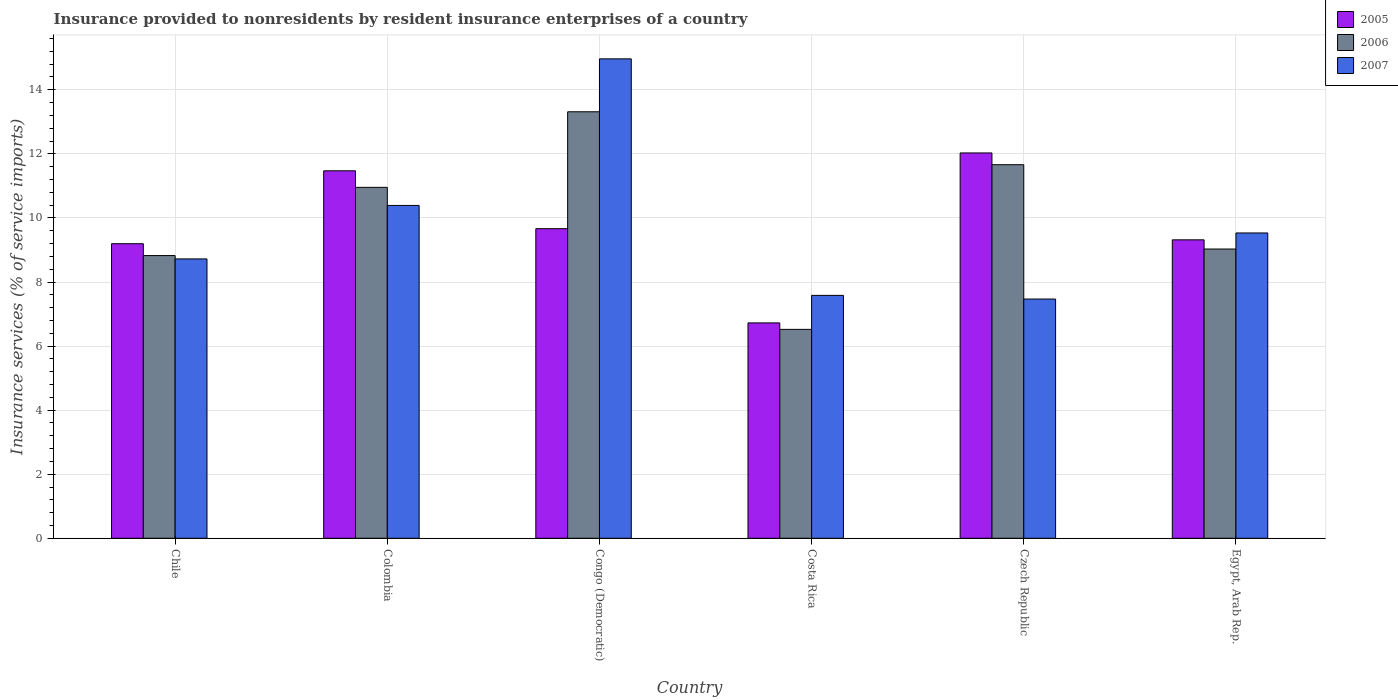How many different coloured bars are there?
Your answer should be very brief. 3. How many groups of bars are there?
Give a very brief answer. 6. Are the number of bars per tick equal to the number of legend labels?
Your answer should be very brief. Yes. Are the number of bars on each tick of the X-axis equal?
Your answer should be very brief. Yes. How many bars are there on the 1st tick from the left?
Your answer should be compact. 3. How many bars are there on the 1st tick from the right?
Your response must be concise. 3. What is the label of the 5th group of bars from the left?
Provide a short and direct response. Czech Republic. What is the insurance provided to nonresidents in 2005 in Czech Republic?
Offer a terse response. 12.03. Across all countries, what is the maximum insurance provided to nonresidents in 2007?
Offer a terse response. 14.97. Across all countries, what is the minimum insurance provided to nonresidents in 2006?
Offer a terse response. 6.52. In which country was the insurance provided to nonresidents in 2006 maximum?
Offer a very short reply. Congo (Democratic). In which country was the insurance provided to nonresidents in 2007 minimum?
Make the answer very short. Czech Republic. What is the total insurance provided to nonresidents in 2005 in the graph?
Your answer should be compact. 58.4. What is the difference between the insurance provided to nonresidents in 2005 in Costa Rica and that in Egypt, Arab Rep.?
Ensure brevity in your answer.  -2.59. What is the difference between the insurance provided to nonresidents in 2005 in Colombia and the insurance provided to nonresidents in 2007 in Czech Republic?
Give a very brief answer. 4. What is the average insurance provided to nonresidents in 2007 per country?
Your answer should be very brief. 9.78. What is the difference between the insurance provided to nonresidents of/in 2007 and insurance provided to nonresidents of/in 2006 in Costa Rica?
Your response must be concise. 1.06. In how many countries, is the insurance provided to nonresidents in 2006 greater than 14 %?
Provide a succinct answer. 0. What is the ratio of the insurance provided to nonresidents in 2006 in Czech Republic to that in Egypt, Arab Rep.?
Your answer should be very brief. 1.29. What is the difference between the highest and the second highest insurance provided to nonresidents in 2007?
Ensure brevity in your answer.  -0.86. What is the difference between the highest and the lowest insurance provided to nonresidents in 2007?
Your response must be concise. 7.5. In how many countries, is the insurance provided to nonresidents in 2005 greater than the average insurance provided to nonresidents in 2005 taken over all countries?
Keep it short and to the point. 2. Is the sum of the insurance provided to nonresidents in 2006 in Chile and Costa Rica greater than the maximum insurance provided to nonresidents in 2005 across all countries?
Your answer should be compact. Yes. Are all the bars in the graph horizontal?
Your answer should be compact. No. How many countries are there in the graph?
Give a very brief answer. 6. Does the graph contain any zero values?
Your answer should be compact. No. Does the graph contain grids?
Make the answer very short. Yes. Where does the legend appear in the graph?
Your answer should be very brief. Top right. What is the title of the graph?
Offer a terse response. Insurance provided to nonresidents by resident insurance enterprises of a country. What is the label or title of the X-axis?
Offer a very short reply. Country. What is the label or title of the Y-axis?
Make the answer very short. Insurance services (% of service imports). What is the Insurance services (% of service imports) in 2005 in Chile?
Provide a succinct answer. 9.2. What is the Insurance services (% of service imports) in 2006 in Chile?
Offer a very short reply. 8.83. What is the Insurance services (% of service imports) of 2007 in Chile?
Provide a short and direct response. 8.72. What is the Insurance services (% of service imports) in 2005 in Colombia?
Your answer should be very brief. 11.47. What is the Insurance services (% of service imports) of 2006 in Colombia?
Give a very brief answer. 10.96. What is the Insurance services (% of service imports) of 2007 in Colombia?
Your response must be concise. 10.39. What is the Insurance services (% of service imports) of 2005 in Congo (Democratic)?
Make the answer very short. 9.66. What is the Insurance services (% of service imports) in 2006 in Congo (Democratic)?
Offer a very short reply. 13.31. What is the Insurance services (% of service imports) in 2007 in Congo (Democratic)?
Give a very brief answer. 14.97. What is the Insurance services (% of service imports) of 2005 in Costa Rica?
Make the answer very short. 6.72. What is the Insurance services (% of service imports) in 2006 in Costa Rica?
Offer a terse response. 6.52. What is the Insurance services (% of service imports) in 2007 in Costa Rica?
Provide a short and direct response. 7.58. What is the Insurance services (% of service imports) in 2005 in Czech Republic?
Provide a succinct answer. 12.03. What is the Insurance services (% of service imports) in 2006 in Czech Republic?
Ensure brevity in your answer.  11.66. What is the Insurance services (% of service imports) of 2007 in Czech Republic?
Offer a terse response. 7.47. What is the Insurance services (% of service imports) in 2005 in Egypt, Arab Rep.?
Keep it short and to the point. 9.32. What is the Insurance services (% of service imports) of 2006 in Egypt, Arab Rep.?
Offer a terse response. 9.03. What is the Insurance services (% of service imports) in 2007 in Egypt, Arab Rep.?
Provide a short and direct response. 9.53. Across all countries, what is the maximum Insurance services (% of service imports) of 2005?
Give a very brief answer. 12.03. Across all countries, what is the maximum Insurance services (% of service imports) in 2006?
Provide a succinct answer. 13.31. Across all countries, what is the maximum Insurance services (% of service imports) in 2007?
Offer a terse response. 14.97. Across all countries, what is the minimum Insurance services (% of service imports) in 2005?
Your answer should be very brief. 6.72. Across all countries, what is the minimum Insurance services (% of service imports) in 2006?
Ensure brevity in your answer.  6.52. Across all countries, what is the minimum Insurance services (% of service imports) in 2007?
Provide a succinct answer. 7.47. What is the total Insurance services (% of service imports) in 2005 in the graph?
Provide a short and direct response. 58.4. What is the total Insurance services (% of service imports) in 2006 in the graph?
Provide a short and direct response. 60.31. What is the total Insurance services (% of service imports) in 2007 in the graph?
Provide a succinct answer. 58.66. What is the difference between the Insurance services (% of service imports) in 2005 in Chile and that in Colombia?
Give a very brief answer. -2.28. What is the difference between the Insurance services (% of service imports) in 2006 in Chile and that in Colombia?
Offer a terse response. -2.13. What is the difference between the Insurance services (% of service imports) in 2007 in Chile and that in Colombia?
Offer a terse response. -1.67. What is the difference between the Insurance services (% of service imports) in 2005 in Chile and that in Congo (Democratic)?
Provide a short and direct response. -0.47. What is the difference between the Insurance services (% of service imports) of 2006 in Chile and that in Congo (Democratic)?
Your answer should be very brief. -4.49. What is the difference between the Insurance services (% of service imports) of 2007 in Chile and that in Congo (Democratic)?
Offer a terse response. -6.25. What is the difference between the Insurance services (% of service imports) of 2005 in Chile and that in Costa Rica?
Make the answer very short. 2.47. What is the difference between the Insurance services (% of service imports) of 2006 in Chile and that in Costa Rica?
Offer a very short reply. 2.3. What is the difference between the Insurance services (% of service imports) in 2007 in Chile and that in Costa Rica?
Make the answer very short. 1.14. What is the difference between the Insurance services (% of service imports) of 2005 in Chile and that in Czech Republic?
Your answer should be compact. -2.83. What is the difference between the Insurance services (% of service imports) of 2006 in Chile and that in Czech Republic?
Provide a short and direct response. -2.84. What is the difference between the Insurance services (% of service imports) in 2007 in Chile and that in Czech Republic?
Keep it short and to the point. 1.25. What is the difference between the Insurance services (% of service imports) in 2005 in Chile and that in Egypt, Arab Rep.?
Offer a very short reply. -0.12. What is the difference between the Insurance services (% of service imports) in 2006 in Chile and that in Egypt, Arab Rep.?
Your response must be concise. -0.2. What is the difference between the Insurance services (% of service imports) in 2007 in Chile and that in Egypt, Arab Rep.?
Ensure brevity in your answer.  -0.81. What is the difference between the Insurance services (% of service imports) of 2005 in Colombia and that in Congo (Democratic)?
Offer a very short reply. 1.81. What is the difference between the Insurance services (% of service imports) of 2006 in Colombia and that in Congo (Democratic)?
Your answer should be very brief. -2.36. What is the difference between the Insurance services (% of service imports) of 2007 in Colombia and that in Congo (Democratic)?
Your answer should be compact. -4.58. What is the difference between the Insurance services (% of service imports) of 2005 in Colombia and that in Costa Rica?
Provide a short and direct response. 4.75. What is the difference between the Insurance services (% of service imports) in 2006 in Colombia and that in Costa Rica?
Offer a terse response. 4.43. What is the difference between the Insurance services (% of service imports) in 2007 in Colombia and that in Costa Rica?
Your response must be concise. 2.81. What is the difference between the Insurance services (% of service imports) of 2005 in Colombia and that in Czech Republic?
Ensure brevity in your answer.  -0.56. What is the difference between the Insurance services (% of service imports) of 2006 in Colombia and that in Czech Republic?
Offer a terse response. -0.71. What is the difference between the Insurance services (% of service imports) of 2007 in Colombia and that in Czech Republic?
Give a very brief answer. 2.92. What is the difference between the Insurance services (% of service imports) of 2005 in Colombia and that in Egypt, Arab Rep.?
Make the answer very short. 2.16. What is the difference between the Insurance services (% of service imports) of 2006 in Colombia and that in Egypt, Arab Rep.?
Your answer should be very brief. 1.93. What is the difference between the Insurance services (% of service imports) of 2007 in Colombia and that in Egypt, Arab Rep.?
Keep it short and to the point. 0.86. What is the difference between the Insurance services (% of service imports) in 2005 in Congo (Democratic) and that in Costa Rica?
Provide a short and direct response. 2.94. What is the difference between the Insurance services (% of service imports) in 2006 in Congo (Democratic) and that in Costa Rica?
Offer a very short reply. 6.79. What is the difference between the Insurance services (% of service imports) of 2007 in Congo (Democratic) and that in Costa Rica?
Provide a short and direct response. 7.38. What is the difference between the Insurance services (% of service imports) of 2005 in Congo (Democratic) and that in Czech Republic?
Offer a terse response. -2.36. What is the difference between the Insurance services (% of service imports) in 2006 in Congo (Democratic) and that in Czech Republic?
Provide a short and direct response. 1.65. What is the difference between the Insurance services (% of service imports) of 2007 in Congo (Democratic) and that in Czech Republic?
Keep it short and to the point. 7.5. What is the difference between the Insurance services (% of service imports) in 2005 in Congo (Democratic) and that in Egypt, Arab Rep.?
Give a very brief answer. 0.35. What is the difference between the Insurance services (% of service imports) of 2006 in Congo (Democratic) and that in Egypt, Arab Rep.?
Offer a very short reply. 4.28. What is the difference between the Insurance services (% of service imports) of 2007 in Congo (Democratic) and that in Egypt, Arab Rep.?
Ensure brevity in your answer.  5.44. What is the difference between the Insurance services (% of service imports) in 2005 in Costa Rica and that in Czech Republic?
Provide a short and direct response. -5.31. What is the difference between the Insurance services (% of service imports) of 2006 in Costa Rica and that in Czech Republic?
Offer a very short reply. -5.14. What is the difference between the Insurance services (% of service imports) in 2007 in Costa Rica and that in Czech Republic?
Give a very brief answer. 0.11. What is the difference between the Insurance services (% of service imports) in 2005 in Costa Rica and that in Egypt, Arab Rep.?
Provide a short and direct response. -2.59. What is the difference between the Insurance services (% of service imports) of 2006 in Costa Rica and that in Egypt, Arab Rep.?
Your answer should be compact. -2.51. What is the difference between the Insurance services (% of service imports) of 2007 in Costa Rica and that in Egypt, Arab Rep.?
Offer a very short reply. -1.95. What is the difference between the Insurance services (% of service imports) of 2005 in Czech Republic and that in Egypt, Arab Rep.?
Your answer should be compact. 2.71. What is the difference between the Insurance services (% of service imports) of 2006 in Czech Republic and that in Egypt, Arab Rep.?
Ensure brevity in your answer.  2.63. What is the difference between the Insurance services (% of service imports) in 2007 in Czech Republic and that in Egypt, Arab Rep.?
Your response must be concise. -2.06. What is the difference between the Insurance services (% of service imports) in 2005 in Chile and the Insurance services (% of service imports) in 2006 in Colombia?
Ensure brevity in your answer.  -1.76. What is the difference between the Insurance services (% of service imports) in 2005 in Chile and the Insurance services (% of service imports) in 2007 in Colombia?
Provide a succinct answer. -1.19. What is the difference between the Insurance services (% of service imports) of 2006 in Chile and the Insurance services (% of service imports) of 2007 in Colombia?
Offer a terse response. -1.57. What is the difference between the Insurance services (% of service imports) of 2005 in Chile and the Insurance services (% of service imports) of 2006 in Congo (Democratic)?
Provide a short and direct response. -4.12. What is the difference between the Insurance services (% of service imports) in 2005 in Chile and the Insurance services (% of service imports) in 2007 in Congo (Democratic)?
Provide a succinct answer. -5.77. What is the difference between the Insurance services (% of service imports) of 2006 in Chile and the Insurance services (% of service imports) of 2007 in Congo (Democratic)?
Your answer should be compact. -6.14. What is the difference between the Insurance services (% of service imports) of 2005 in Chile and the Insurance services (% of service imports) of 2006 in Costa Rica?
Offer a very short reply. 2.67. What is the difference between the Insurance services (% of service imports) of 2005 in Chile and the Insurance services (% of service imports) of 2007 in Costa Rica?
Your answer should be compact. 1.61. What is the difference between the Insurance services (% of service imports) of 2006 in Chile and the Insurance services (% of service imports) of 2007 in Costa Rica?
Offer a terse response. 1.24. What is the difference between the Insurance services (% of service imports) in 2005 in Chile and the Insurance services (% of service imports) in 2006 in Czech Republic?
Provide a succinct answer. -2.47. What is the difference between the Insurance services (% of service imports) of 2005 in Chile and the Insurance services (% of service imports) of 2007 in Czech Republic?
Your answer should be very brief. 1.73. What is the difference between the Insurance services (% of service imports) of 2006 in Chile and the Insurance services (% of service imports) of 2007 in Czech Republic?
Your response must be concise. 1.36. What is the difference between the Insurance services (% of service imports) of 2005 in Chile and the Insurance services (% of service imports) of 2006 in Egypt, Arab Rep.?
Your answer should be compact. 0.17. What is the difference between the Insurance services (% of service imports) in 2005 in Chile and the Insurance services (% of service imports) in 2007 in Egypt, Arab Rep.?
Give a very brief answer. -0.34. What is the difference between the Insurance services (% of service imports) in 2006 in Chile and the Insurance services (% of service imports) in 2007 in Egypt, Arab Rep.?
Your response must be concise. -0.71. What is the difference between the Insurance services (% of service imports) in 2005 in Colombia and the Insurance services (% of service imports) in 2006 in Congo (Democratic)?
Your answer should be very brief. -1.84. What is the difference between the Insurance services (% of service imports) in 2005 in Colombia and the Insurance services (% of service imports) in 2007 in Congo (Democratic)?
Your answer should be compact. -3.49. What is the difference between the Insurance services (% of service imports) in 2006 in Colombia and the Insurance services (% of service imports) in 2007 in Congo (Democratic)?
Make the answer very short. -4.01. What is the difference between the Insurance services (% of service imports) of 2005 in Colombia and the Insurance services (% of service imports) of 2006 in Costa Rica?
Make the answer very short. 4.95. What is the difference between the Insurance services (% of service imports) in 2005 in Colombia and the Insurance services (% of service imports) in 2007 in Costa Rica?
Provide a short and direct response. 3.89. What is the difference between the Insurance services (% of service imports) of 2006 in Colombia and the Insurance services (% of service imports) of 2007 in Costa Rica?
Your answer should be very brief. 3.37. What is the difference between the Insurance services (% of service imports) in 2005 in Colombia and the Insurance services (% of service imports) in 2006 in Czech Republic?
Ensure brevity in your answer.  -0.19. What is the difference between the Insurance services (% of service imports) in 2005 in Colombia and the Insurance services (% of service imports) in 2007 in Czech Republic?
Make the answer very short. 4. What is the difference between the Insurance services (% of service imports) of 2006 in Colombia and the Insurance services (% of service imports) of 2007 in Czech Republic?
Provide a succinct answer. 3.49. What is the difference between the Insurance services (% of service imports) of 2005 in Colombia and the Insurance services (% of service imports) of 2006 in Egypt, Arab Rep.?
Your response must be concise. 2.44. What is the difference between the Insurance services (% of service imports) of 2005 in Colombia and the Insurance services (% of service imports) of 2007 in Egypt, Arab Rep.?
Provide a succinct answer. 1.94. What is the difference between the Insurance services (% of service imports) of 2006 in Colombia and the Insurance services (% of service imports) of 2007 in Egypt, Arab Rep.?
Offer a terse response. 1.42. What is the difference between the Insurance services (% of service imports) in 2005 in Congo (Democratic) and the Insurance services (% of service imports) in 2006 in Costa Rica?
Provide a short and direct response. 3.14. What is the difference between the Insurance services (% of service imports) of 2005 in Congo (Democratic) and the Insurance services (% of service imports) of 2007 in Costa Rica?
Offer a very short reply. 2.08. What is the difference between the Insurance services (% of service imports) in 2006 in Congo (Democratic) and the Insurance services (% of service imports) in 2007 in Costa Rica?
Offer a terse response. 5.73. What is the difference between the Insurance services (% of service imports) of 2005 in Congo (Democratic) and the Insurance services (% of service imports) of 2006 in Czech Republic?
Your response must be concise. -2. What is the difference between the Insurance services (% of service imports) of 2005 in Congo (Democratic) and the Insurance services (% of service imports) of 2007 in Czech Republic?
Give a very brief answer. 2.2. What is the difference between the Insurance services (% of service imports) in 2006 in Congo (Democratic) and the Insurance services (% of service imports) in 2007 in Czech Republic?
Provide a succinct answer. 5.85. What is the difference between the Insurance services (% of service imports) in 2005 in Congo (Democratic) and the Insurance services (% of service imports) in 2006 in Egypt, Arab Rep.?
Your answer should be very brief. 0.63. What is the difference between the Insurance services (% of service imports) of 2005 in Congo (Democratic) and the Insurance services (% of service imports) of 2007 in Egypt, Arab Rep.?
Offer a very short reply. 0.13. What is the difference between the Insurance services (% of service imports) in 2006 in Congo (Democratic) and the Insurance services (% of service imports) in 2007 in Egypt, Arab Rep.?
Your answer should be very brief. 3.78. What is the difference between the Insurance services (% of service imports) of 2005 in Costa Rica and the Insurance services (% of service imports) of 2006 in Czech Republic?
Your response must be concise. -4.94. What is the difference between the Insurance services (% of service imports) of 2005 in Costa Rica and the Insurance services (% of service imports) of 2007 in Czech Republic?
Provide a short and direct response. -0.74. What is the difference between the Insurance services (% of service imports) of 2006 in Costa Rica and the Insurance services (% of service imports) of 2007 in Czech Republic?
Your answer should be very brief. -0.95. What is the difference between the Insurance services (% of service imports) of 2005 in Costa Rica and the Insurance services (% of service imports) of 2006 in Egypt, Arab Rep.?
Offer a terse response. -2.31. What is the difference between the Insurance services (% of service imports) in 2005 in Costa Rica and the Insurance services (% of service imports) in 2007 in Egypt, Arab Rep.?
Your answer should be compact. -2.81. What is the difference between the Insurance services (% of service imports) in 2006 in Costa Rica and the Insurance services (% of service imports) in 2007 in Egypt, Arab Rep.?
Your answer should be compact. -3.01. What is the difference between the Insurance services (% of service imports) in 2005 in Czech Republic and the Insurance services (% of service imports) in 2006 in Egypt, Arab Rep.?
Your response must be concise. 3. What is the difference between the Insurance services (% of service imports) of 2005 in Czech Republic and the Insurance services (% of service imports) of 2007 in Egypt, Arab Rep.?
Provide a short and direct response. 2.5. What is the difference between the Insurance services (% of service imports) of 2006 in Czech Republic and the Insurance services (% of service imports) of 2007 in Egypt, Arab Rep.?
Provide a succinct answer. 2.13. What is the average Insurance services (% of service imports) of 2005 per country?
Your response must be concise. 9.73. What is the average Insurance services (% of service imports) of 2006 per country?
Offer a very short reply. 10.05. What is the average Insurance services (% of service imports) of 2007 per country?
Your answer should be very brief. 9.78. What is the difference between the Insurance services (% of service imports) of 2005 and Insurance services (% of service imports) of 2006 in Chile?
Provide a succinct answer. 0.37. What is the difference between the Insurance services (% of service imports) of 2005 and Insurance services (% of service imports) of 2007 in Chile?
Ensure brevity in your answer.  0.47. What is the difference between the Insurance services (% of service imports) of 2006 and Insurance services (% of service imports) of 2007 in Chile?
Provide a short and direct response. 0.1. What is the difference between the Insurance services (% of service imports) of 2005 and Insurance services (% of service imports) of 2006 in Colombia?
Provide a short and direct response. 0.52. What is the difference between the Insurance services (% of service imports) of 2005 and Insurance services (% of service imports) of 2007 in Colombia?
Your response must be concise. 1.08. What is the difference between the Insurance services (% of service imports) of 2006 and Insurance services (% of service imports) of 2007 in Colombia?
Offer a terse response. 0.56. What is the difference between the Insurance services (% of service imports) of 2005 and Insurance services (% of service imports) of 2006 in Congo (Democratic)?
Provide a succinct answer. -3.65. What is the difference between the Insurance services (% of service imports) in 2005 and Insurance services (% of service imports) in 2007 in Congo (Democratic)?
Your answer should be very brief. -5.3. What is the difference between the Insurance services (% of service imports) in 2006 and Insurance services (% of service imports) in 2007 in Congo (Democratic)?
Make the answer very short. -1.65. What is the difference between the Insurance services (% of service imports) of 2005 and Insurance services (% of service imports) of 2006 in Costa Rica?
Make the answer very short. 0.2. What is the difference between the Insurance services (% of service imports) of 2005 and Insurance services (% of service imports) of 2007 in Costa Rica?
Give a very brief answer. -0.86. What is the difference between the Insurance services (% of service imports) of 2006 and Insurance services (% of service imports) of 2007 in Costa Rica?
Keep it short and to the point. -1.06. What is the difference between the Insurance services (% of service imports) of 2005 and Insurance services (% of service imports) of 2006 in Czech Republic?
Make the answer very short. 0.37. What is the difference between the Insurance services (% of service imports) of 2005 and Insurance services (% of service imports) of 2007 in Czech Republic?
Your response must be concise. 4.56. What is the difference between the Insurance services (% of service imports) in 2006 and Insurance services (% of service imports) in 2007 in Czech Republic?
Your response must be concise. 4.19. What is the difference between the Insurance services (% of service imports) in 2005 and Insurance services (% of service imports) in 2006 in Egypt, Arab Rep.?
Keep it short and to the point. 0.29. What is the difference between the Insurance services (% of service imports) in 2005 and Insurance services (% of service imports) in 2007 in Egypt, Arab Rep.?
Keep it short and to the point. -0.21. What is the difference between the Insurance services (% of service imports) in 2006 and Insurance services (% of service imports) in 2007 in Egypt, Arab Rep.?
Your response must be concise. -0.5. What is the ratio of the Insurance services (% of service imports) of 2005 in Chile to that in Colombia?
Provide a succinct answer. 0.8. What is the ratio of the Insurance services (% of service imports) in 2006 in Chile to that in Colombia?
Your response must be concise. 0.81. What is the ratio of the Insurance services (% of service imports) in 2007 in Chile to that in Colombia?
Your answer should be compact. 0.84. What is the ratio of the Insurance services (% of service imports) in 2005 in Chile to that in Congo (Democratic)?
Keep it short and to the point. 0.95. What is the ratio of the Insurance services (% of service imports) of 2006 in Chile to that in Congo (Democratic)?
Your response must be concise. 0.66. What is the ratio of the Insurance services (% of service imports) in 2007 in Chile to that in Congo (Democratic)?
Your answer should be compact. 0.58. What is the ratio of the Insurance services (% of service imports) in 2005 in Chile to that in Costa Rica?
Give a very brief answer. 1.37. What is the ratio of the Insurance services (% of service imports) in 2006 in Chile to that in Costa Rica?
Ensure brevity in your answer.  1.35. What is the ratio of the Insurance services (% of service imports) in 2007 in Chile to that in Costa Rica?
Ensure brevity in your answer.  1.15. What is the ratio of the Insurance services (% of service imports) of 2005 in Chile to that in Czech Republic?
Provide a short and direct response. 0.76. What is the ratio of the Insurance services (% of service imports) of 2006 in Chile to that in Czech Republic?
Your answer should be very brief. 0.76. What is the ratio of the Insurance services (% of service imports) of 2007 in Chile to that in Czech Republic?
Your answer should be very brief. 1.17. What is the ratio of the Insurance services (% of service imports) of 2006 in Chile to that in Egypt, Arab Rep.?
Ensure brevity in your answer.  0.98. What is the ratio of the Insurance services (% of service imports) in 2007 in Chile to that in Egypt, Arab Rep.?
Make the answer very short. 0.92. What is the ratio of the Insurance services (% of service imports) in 2005 in Colombia to that in Congo (Democratic)?
Offer a terse response. 1.19. What is the ratio of the Insurance services (% of service imports) of 2006 in Colombia to that in Congo (Democratic)?
Keep it short and to the point. 0.82. What is the ratio of the Insurance services (% of service imports) in 2007 in Colombia to that in Congo (Democratic)?
Ensure brevity in your answer.  0.69. What is the ratio of the Insurance services (% of service imports) of 2005 in Colombia to that in Costa Rica?
Your answer should be compact. 1.71. What is the ratio of the Insurance services (% of service imports) in 2006 in Colombia to that in Costa Rica?
Your answer should be very brief. 1.68. What is the ratio of the Insurance services (% of service imports) in 2007 in Colombia to that in Costa Rica?
Make the answer very short. 1.37. What is the ratio of the Insurance services (% of service imports) of 2005 in Colombia to that in Czech Republic?
Keep it short and to the point. 0.95. What is the ratio of the Insurance services (% of service imports) of 2006 in Colombia to that in Czech Republic?
Offer a very short reply. 0.94. What is the ratio of the Insurance services (% of service imports) in 2007 in Colombia to that in Czech Republic?
Your answer should be compact. 1.39. What is the ratio of the Insurance services (% of service imports) of 2005 in Colombia to that in Egypt, Arab Rep.?
Offer a very short reply. 1.23. What is the ratio of the Insurance services (% of service imports) of 2006 in Colombia to that in Egypt, Arab Rep.?
Give a very brief answer. 1.21. What is the ratio of the Insurance services (% of service imports) of 2007 in Colombia to that in Egypt, Arab Rep.?
Keep it short and to the point. 1.09. What is the ratio of the Insurance services (% of service imports) of 2005 in Congo (Democratic) to that in Costa Rica?
Your answer should be compact. 1.44. What is the ratio of the Insurance services (% of service imports) in 2006 in Congo (Democratic) to that in Costa Rica?
Give a very brief answer. 2.04. What is the ratio of the Insurance services (% of service imports) in 2007 in Congo (Democratic) to that in Costa Rica?
Give a very brief answer. 1.97. What is the ratio of the Insurance services (% of service imports) in 2005 in Congo (Democratic) to that in Czech Republic?
Provide a succinct answer. 0.8. What is the ratio of the Insurance services (% of service imports) of 2006 in Congo (Democratic) to that in Czech Republic?
Provide a short and direct response. 1.14. What is the ratio of the Insurance services (% of service imports) in 2007 in Congo (Democratic) to that in Czech Republic?
Give a very brief answer. 2. What is the ratio of the Insurance services (% of service imports) in 2005 in Congo (Democratic) to that in Egypt, Arab Rep.?
Keep it short and to the point. 1.04. What is the ratio of the Insurance services (% of service imports) of 2006 in Congo (Democratic) to that in Egypt, Arab Rep.?
Give a very brief answer. 1.47. What is the ratio of the Insurance services (% of service imports) of 2007 in Congo (Democratic) to that in Egypt, Arab Rep.?
Give a very brief answer. 1.57. What is the ratio of the Insurance services (% of service imports) of 2005 in Costa Rica to that in Czech Republic?
Your response must be concise. 0.56. What is the ratio of the Insurance services (% of service imports) in 2006 in Costa Rica to that in Czech Republic?
Your response must be concise. 0.56. What is the ratio of the Insurance services (% of service imports) of 2007 in Costa Rica to that in Czech Republic?
Give a very brief answer. 1.02. What is the ratio of the Insurance services (% of service imports) in 2005 in Costa Rica to that in Egypt, Arab Rep.?
Your answer should be compact. 0.72. What is the ratio of the Insurance services (% of service imports) of 2006 in Costa Rica to that in Egypt, Arab Rep.?
Your answer should be very brief. 0.72. What is the ratio of the Insurance services (% of service imports) of 2007 in Costa Rica to that in Egypt, Arab Rep.?
Your answer should be compact. 0.8. What is the ratio of the Insurance services (% of service imports) of 2005 in Czech Republic to that in Egypt, Arab Rep.?
Offer a terse response. 1.29. What is the ratio of the Insurance services (% of service imports) in 2006 in Czech Republic to that in Egypt, Arab Rep.?
Your answer should be compact. 1.29. What is the ratio of the Insurance services (% of service imports) of 2007 in Czech Republic to that in Egypt, Arab Rep.?
Ensure brevity in your answer.  0.78. What is the difference between the highest and the second highest Insurance services (% of service imports) in 2005?
Ensure brevity in your answer.  0.56. What is the difference between the highest and the second highest Insurance services (% of service imports) in 2006?
Ensure brevity in your answer.  1.65. What is the difference between the highest and the second highest Insurance services (% of service imports) of 2007?
Ensure brevity in your answer.  4.58. What is the difference between the highest and the lowest Insurance services (% of service imports) of 2005?
Give a very brief answer. 5.31. What is the difference between the highest and the lowest Insurance services (% of service imports) in 2006?
Give a very brief answer. 6.79. What is the difference between the highest and the lowest Insurance services (% of service imports) in 2007?
Make the answer very short. 7.5. 